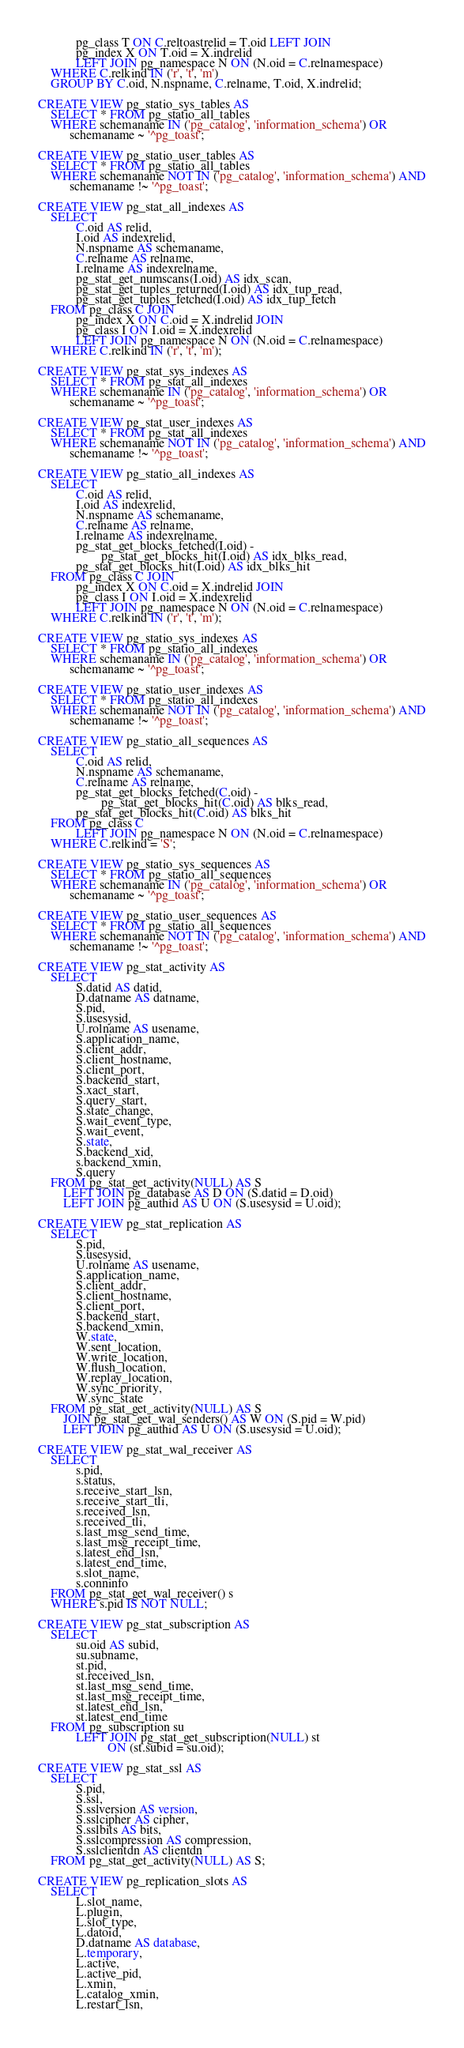Convert code to text. <code><loc_0><loc_0><loc_500><loc_500><_SQL_>            pg_class T ON C.reltoastrelid = T.oid LEFT JOIN
            pg_index X ON T.oid = X.indrelid
            LEFT JOIN pg_namespace N ON (N.oid = C.relnamespace)
    WHERE C.relkind IN ('r', 't', 'm')
    GROUP BY C.oid, N.nspname, C.relname, T.oid, X.indrelid;

CREATE VIEW pg_statio_sys_tables AS
    SELECT * FROM pg_statio_all_tables
    WHERE schemaname IN ('pg_catalog', 'information_schema') OR
          schemaname ~ '^pg_toast';

CREATE VIEW pg_statio_user_tables AS
    SELECT * FROM pg_statio_all_tables
    WHERE schemaname NOT IN ('pg_catalog', 'information_schema') AND
          schemaname !~ '^pg_toast';

CREATE VIEW pg_stat_all_indexes AS
    SELECT
            C.oid AS relid,
            I.oid AS indexrelid,
            N.nspname AS schemaname,
            C.relname AS relname,
            I.relname AS indexrelname,
            pg_stat_get_numscans(I.oid) AS idx_scan,
            pg_stat_get_tuples_returned(I.oid) AS idx_tup_read,
            pg_stat_get_tuples_fetched(I.oid) AS idx_tup_fetch
    FROM pg_class C JOIN
            pg_index X ON C.oid = X.indrelid JOIN
            pg_class I ON I.oid = X.indexrelid
            LEFT JOIN pg_namespace N ON (N.oid = C.relnamespace)
    WHERE C.relkind IN ('r', 't', 'm');

CREATE VIEW pg_stat_sys_indexes AS
    SELECT * FROM pg_stat_all_indexes
    WHERE schemaname IN ('pg_catalog', 'information_schema') OR
          schemaname ~ '^pg_toast';

CREATE VIEW pg_stat_user_indexes AS
    SELECT * FROM pg_stat_all_indexes
    WHERE schemaname NOT IN ('pg_catalog', 'information_schema') AND
          schemaname !~ '^pg_toast';

CREATE VIEW pg_statio_all_indexes AS
    SELECT
            C.oid AS relid,
            I.oid AS indexrelid,
            N.nspname AS schemaname,
            C.relname AS relname,
            I.relname AS indexrelname,
            pg_stat_get_blocks_fetched(I.oid) -
                    pg_stat_get_blocks_hit(I.oid) AS idx_blks_read,
            pg_stat_get_blocks_hit(I.oid) AS idx_blks_hit
    FROM pg_class C JOIN
            pg_index X ON C.oid = X.indrelid JOIN
            pg_class I ON I.oid = X.indexrelid
            LEFT JOIN pg_namespace N ON (N.oid = C.relnamespace)
    WHERE C.relkind IN ('r', 't', 'm');

CREATE VIEW pg_statio_sys_indexes AS
    SELECT * FROM pg_statio_all_indexes
    WHERE schemaname IN ('pg_catalog', 'information_schema') OR
          schemaname ~ '^pg_toast';

CREATE VIEW pg_statio_user_indexes AS
    SELECT * FROM pg_statio_all_indexes
    WHERE schemaname NOT IN ('pg_catalog', 'information_schema') AND
          schemaname !~ '^pg_toast';

CREATE VIEW pg_statio_all_sequences AS
    SELECT
            C.oid AS relid,
            N.nspname AS schemaname,
            C.relname AS relname,
            pg_stat_get_blocks_fetched(C.oid) -
                    pg_stat_get_blocks_hit(C.oid) AS blks_read,
            pg_stat_get_blocks_hit(C.oid) AS blks_hit
    FROM pg_class C
            LEFT JOIN pg_namespace N ON (N.oid = C.relnamespace)
    WHERE C.relkind = 'S';

CREATE VIEW pg_statio_sys_sequences AS
    SELECT * FROM pg_statio_all_sequences
    WHERE schemaname IN ('pg_catalog', 'information_schema') OR
          schemaname ~ '^pg_toast';

CREATE VIEW pg_statio_user_sequences AS
    SELECT * FROM pg_statio_all_sequences
    WHERE schemaname NOT IN ('pg_catalog', 'information_schema') AND
          schemaname !~ '^pg_toast';

CREATE VIEW pg_stat_activity AS
    SELECT
            S.datid AS datid,
            D.datname AS datname,
            S.pid,
            S.usesysid,
            U.rolname AS usename,
            S.application_name,
            S.client_addr,
            S.client_hostname,
            S.client_port,
            S.backend_start,
            S.xact_start,
            S.query_start,
            S.state_change,
            S.wait_event_type,
            S.wait_event,
            S.state,
            S.backend_xid,
            s.backend_xmin,
            S.query
    FROM pg_stat_get_activity(NULL) AS S
        LEFT JOIN pg_database AS D ON (S.datid = D.oid)
        LEFT JOIN pg_authid AS U ON (S.usesysid = U.oid);

CREATE VIEW pg_stat_replication AS
    SELECT
            S.pid,
            S.usesysid,
            U.rolname AS usename,
            S.application_name,
            S.client_addr,
            S.client_hostname,
            S.client_port,
            S.backend_start,
            S.backend_xmin,
            W.state,
            W.sent_location,
            W.write_location,
            W.flush_location,
            W.replay_location,
            W.sync_priority,
            W.sync_state
    FROM pg_stat_get_activity(NULL) AS S
        JOIN pg_stat_get_wal_senders() AS W ON (S.pid = W.pid)
        LEFT JOIN pg_authid AS U ON (S.usesysid = U.oid);

CREATE VIEW pg_stat_wal_receiver AS
    SELECT
            s.pid,
            s.status,
            s.receive_start_lsn,
            s.receive_start_tli,
            s.received_lsn,
            s.received_tli,
            s.last_msg_send_time,
            s.last_msg_receipt_time,
            s.latest_end_lsn,
            s.latest_end_time,
            s.slot_name,
            s.conninfo
    FROM pg_stat_get_wal_receiver() s
    WHERE s.pid IS NOT NULL;

CREATE VIEW pg_stat_subscription AS
    SELECT
            su.oid AS subid,
            su.subname,
            st.pid,
            st.received_lsn,
            st.last_msg_send_time,
            st.last_msg_receipt_time,
            st.latest_end_lsn,
            st.latest_end_time
    FROM pg_subscription su
            LEFT JOIN pg_stat_get_subscription(NULL) st
                      ON (st.subid = su.oid);

CREATE VIEW pg_stat_ssl AS
    SELECT
            S.pid,
            S.ssl,
            S.sslversion AS version,
            S.sslcipher AS cipher,
            S.sslbits AS bits,
            S.sslcompression AS compression,
            S.sslclientdn AS clientdn
    FROM pg_stat_get_activity(NULL) AS S;

CREATE VIEW pg_replication_slots AS
    SELECT
            L.slot_name,
            L.plugin,
            L.slot_type,
            L.datoid,
            D.datname AS database,
            L.temporary,
            L.active,
            L.active_pid,
            L.xmin,
            L.catalog_xmin,
            L.restart_lsn,</code> 